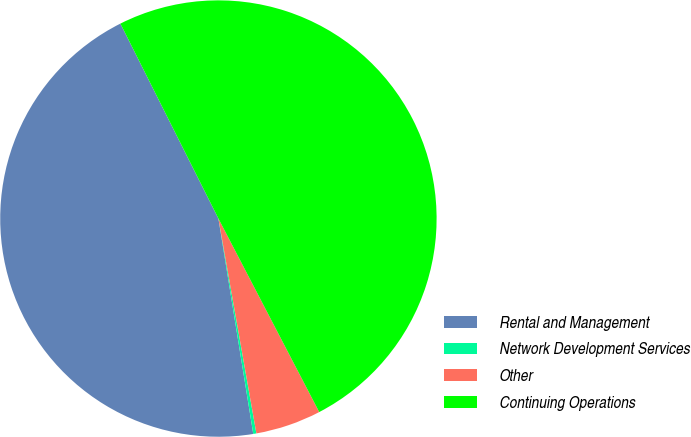Convert chart. <chart><loc_0><loc_0><loc_500><loc_500><pie_chart><fcel>Rental and Management<fcel>Network Development Services<fcel>Other<fcel>Continuing Operations<nl><fcel>45.14%<fcel>0.23%<fcel>4.86%<fcel>49.77%<nl></chart> 